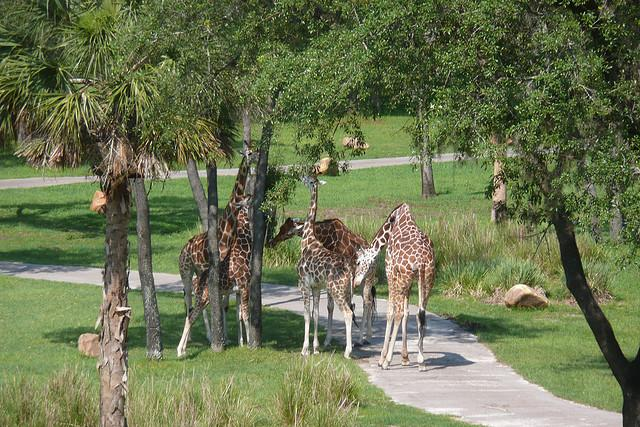Where are these animals most likely to be found in their natural habitat? Please explain your reasoning. africa. The animals are from africa. 